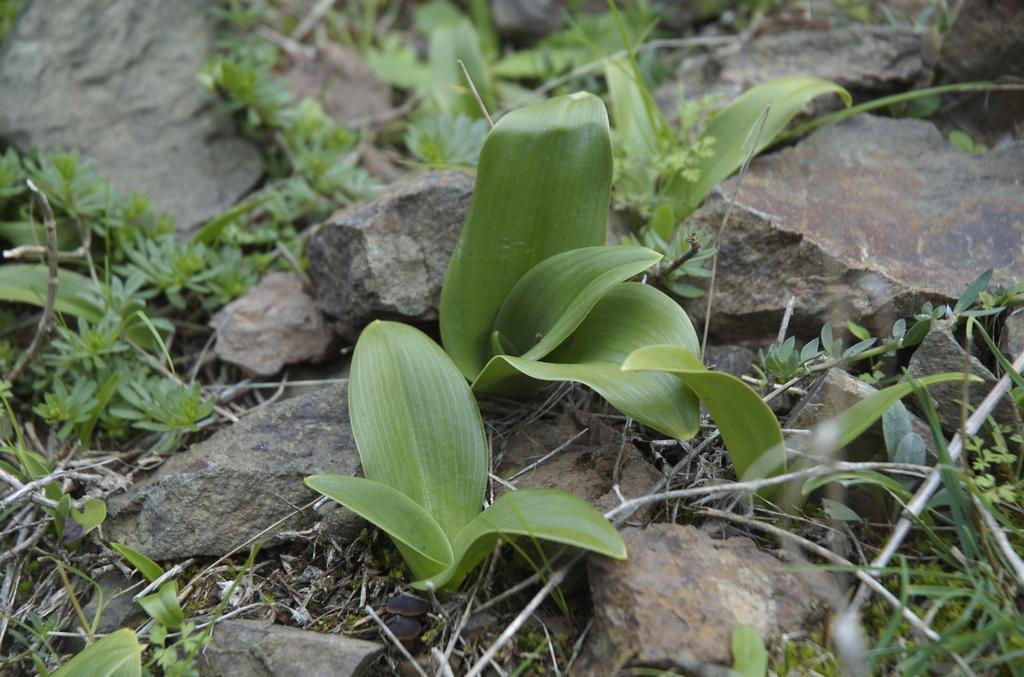What type of vegetation is present in the image? There is grass and plants in the image. What other objects can be seen in the image? There are stones in the image. Where is the scarecrow located in the image? There is no scarecrow present in the image. What color is the paint on the mailbox in the image? There is no mailbox present in the image. 